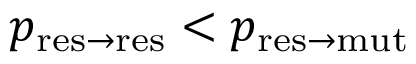<formula> <loc_0><loc_0><loc_500><loc_500>p _ { r e s \to r e s } < p _ { r e s \to m u t }</formula> 